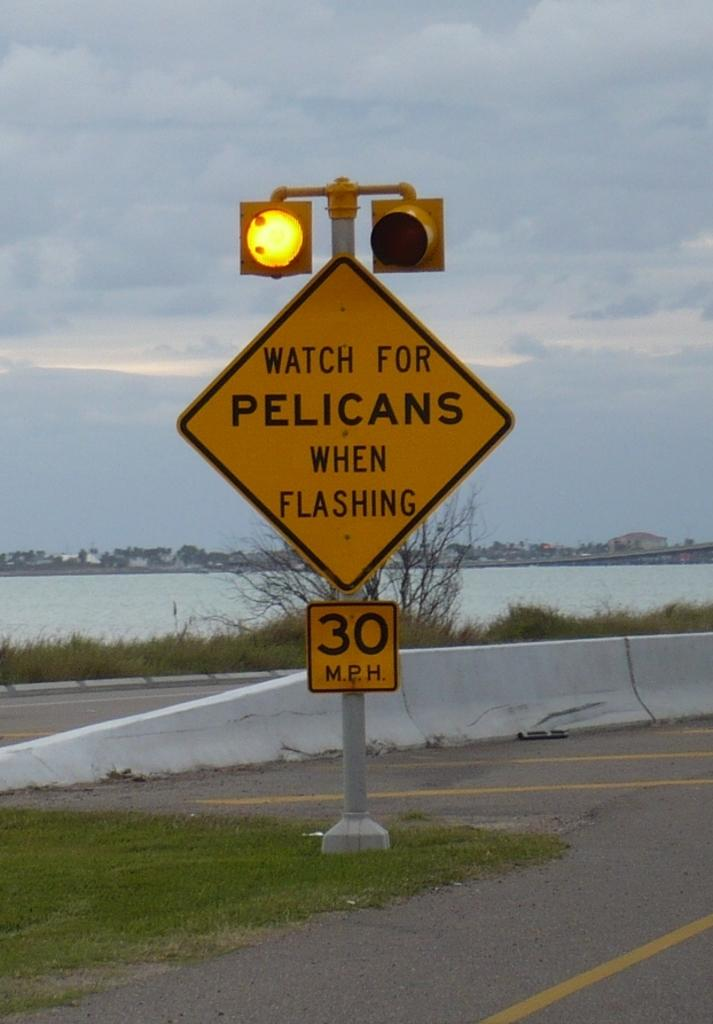<image>
Create a compact narrative representing the image presented. The flashing light warns motorists to watch out for pelicans. 